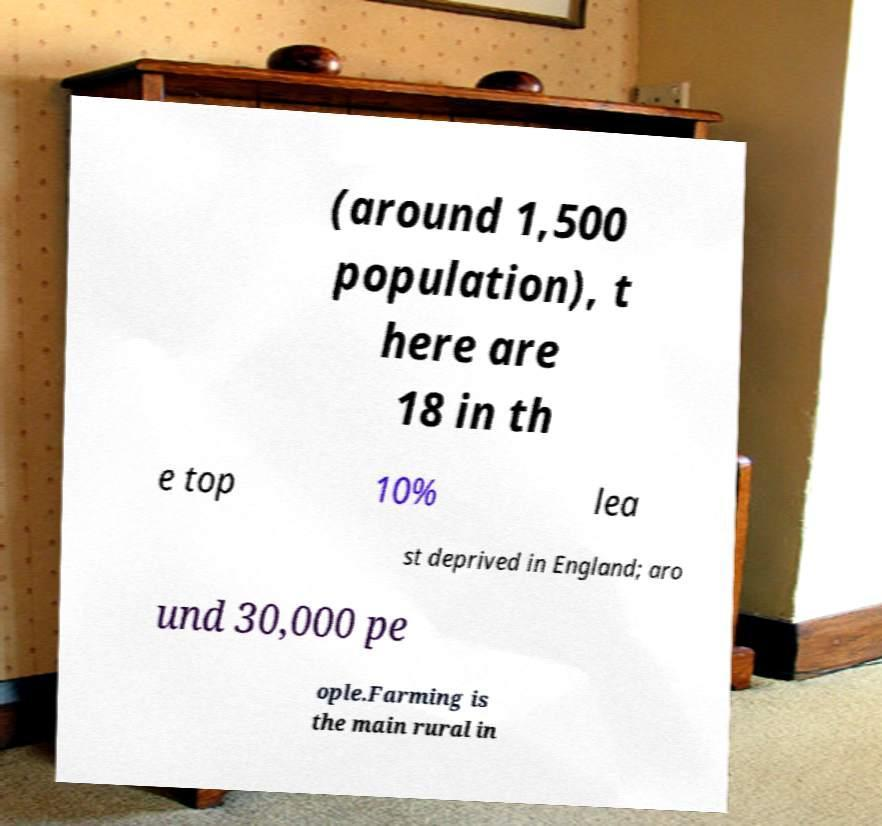What messages or text are displayed in this image? I need them in a readable, typed format. (around 1,500 population), t here are 18 in th e top 10% lea st deprived in England; aro und 30,000 pe ople.Farming is the main rural in 